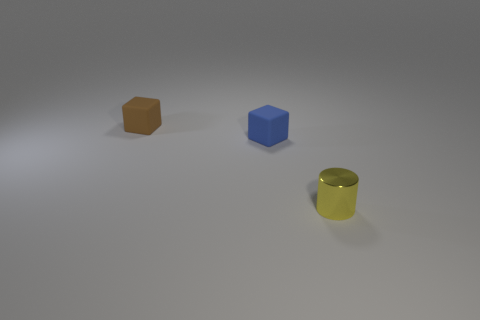What shape is the other thing that is made of the same material as the brown thing?
Provide a succinct answer. Cube. There is a rubber thing that is right of the brown block; is its shape the same as the tiny shiny thing?
Offer a very short reply. No. How many things are either tiny blue rubber objects or red matte objects?
Keep it short and to the point. 1. Is the size of the blue block the same as the yellow thing?
Your answer should be very brief. Yes. What number of things are both to the right of the brown rubber cube and on the left side of the tiny yellow metallic cylinder?
Your response must be concise. 1. There is a thing in front of the tiny rubber cube in front of the brown thing; is there a yellow shiny thing that is in front of it?
Offer a terse response. No. What shape is the other matte thing that is the same size as the brown rubber thing?
Give a very brief answer. Cube. Does the small brown rubber thing have the same shape as the blue rubber object?
Provide a short and direct response. Yes. What number of small objects are brown cubes or blue things?
Offer a very short reply. 2. There is another small thing that is made of the same material as the brown thing; what is its color?
Make the answer very short. Blue. 